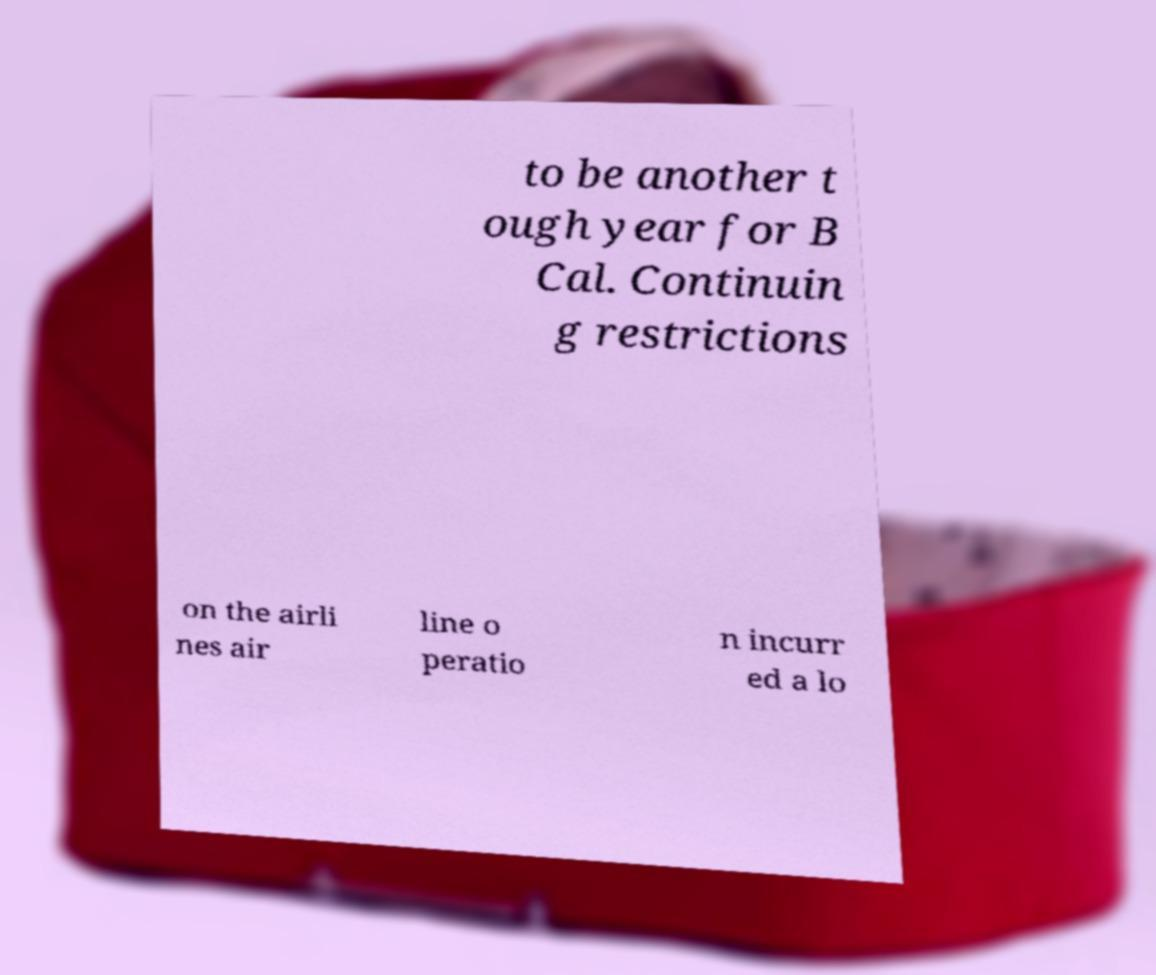Can you accurately transcribe the text from the provided image for me? to be another t ough year for B Cal. Continuin g restrictions on the airli nes air line o peratio n incurr ed a lo 